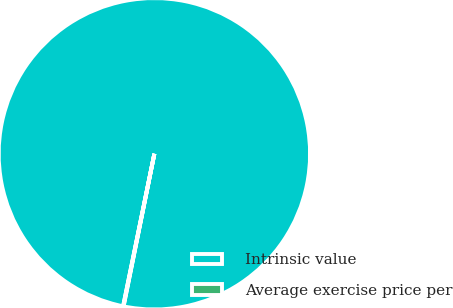Convert chart. <chart><loc_0><loc_0><loc_500><loc_500><pie_chart><fcel>Intrinsic value<fcel>Average exercise price per<nl><fcel>99.95%<fcel>0.05%<nl></chart> 